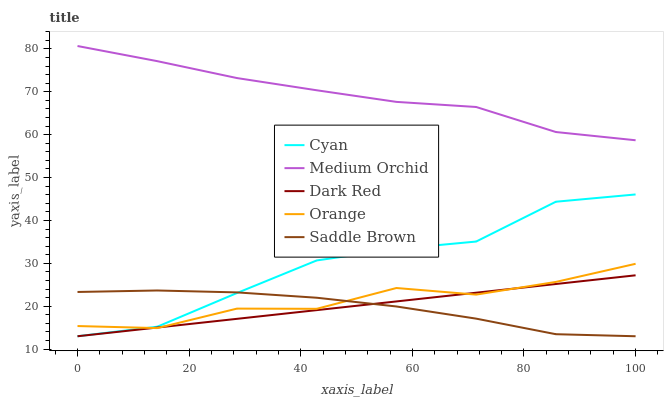Does Saddle Brown have the minimum area under the curve?
Answer yes or no. Yes. Does Medium Orchid have the maximum area under the curve?
Answer yes or no. Yes. Does Cyan have the minimum area under the curve?
Answer yes or no. No. Does Cyan have the maximum area under the curve?
Answer yes or no. No. Is Dark Red the smoothest?
Answer yes or no. Yes. Is Cyan the roughest?
Answer yes or no. Yes. Is Medium Orchid the smoothest?
Answer yes or no. No. Is Medium Orchid the roughest?
Answer yes or no. No. Does Cyan have the lowest value?
Answer yes or no. Yes. Does Medium Orchid have the lowest value?
Answer yes or no. No. Does Medium Orchid have the highest value?
Answer yes or no. Yes. Does Cyan have the highest value?
Answer yes or no. No. Is Cyan less than Medium Orchid?
Answer yes or no. Yes. Is Medium Orchid greater than Saddle Brown?
Answer yes or no. Yes. Does Saddle Brown intersect Dark Red?
Answer yes or no. Yes. Is Saddle Brown less than Dark Red?
Answer yes or no. No. Is Saddle Brown greater than Dark Red?
Answer yes or no. No. Does Cyan intersect Medium Orchid?
Answer yes or no. No. 